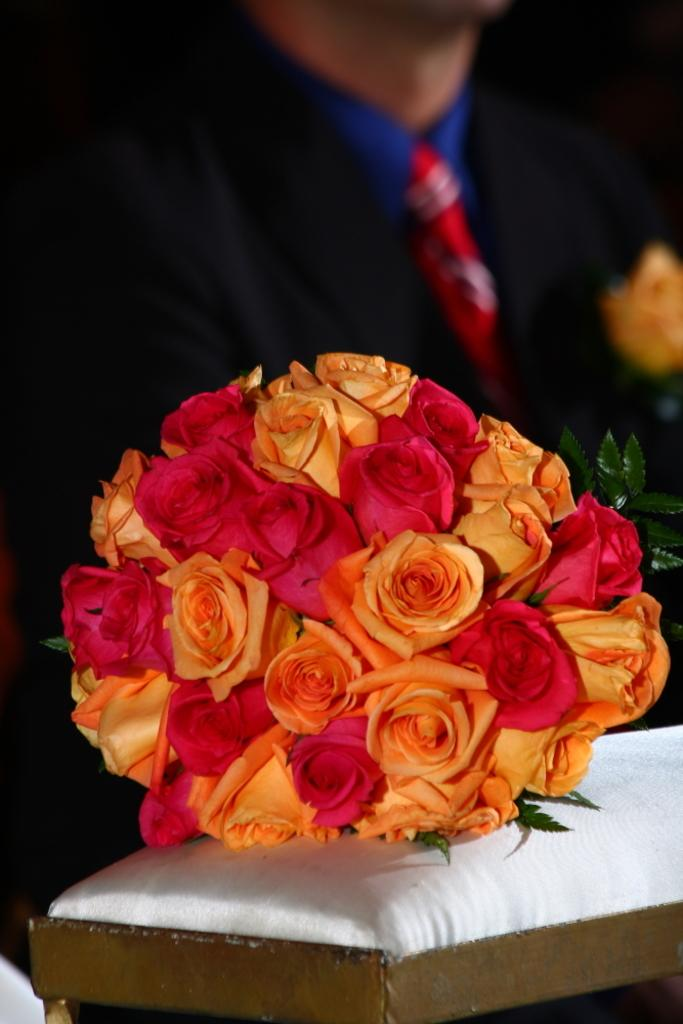What is the main subject in the center of the image? There is a bouquet in the center of the image. Where is the bouquet located? The bouquet is placed on a table. Can you describe anything in the background of the image? There is a man in the background of the image. What type of whip can be seen in the image? There is no whip present in the image. Is there a playground visible in the image? No, there is no playground visible in the image. 